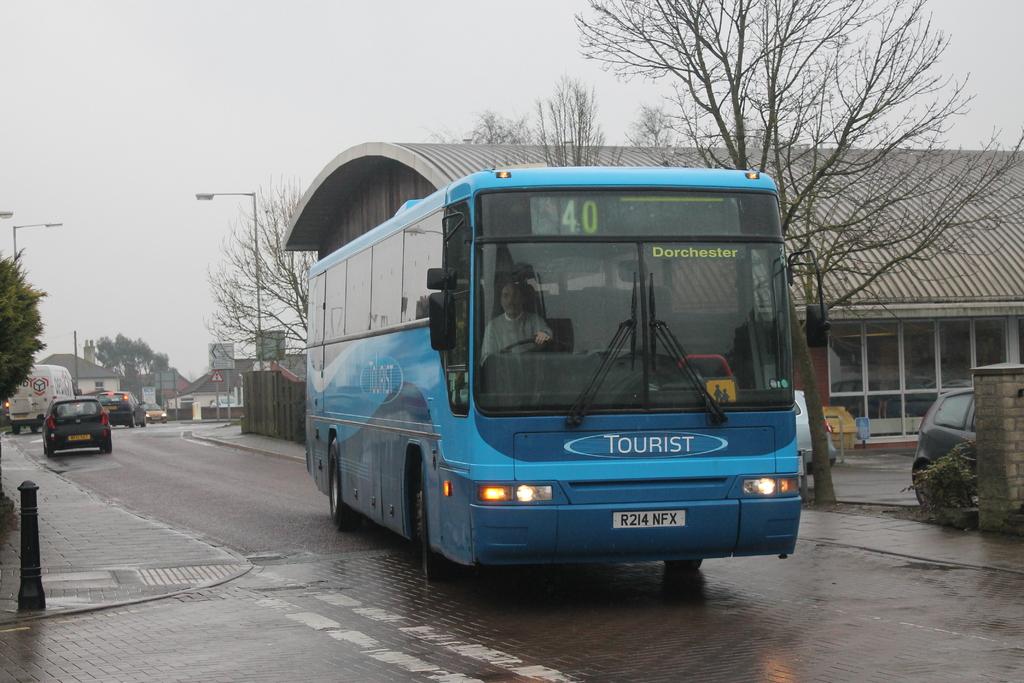Where is this bus going?
Offer a very short reply. Dorchester. What number is this bus?
Offer a terse response. 40. 